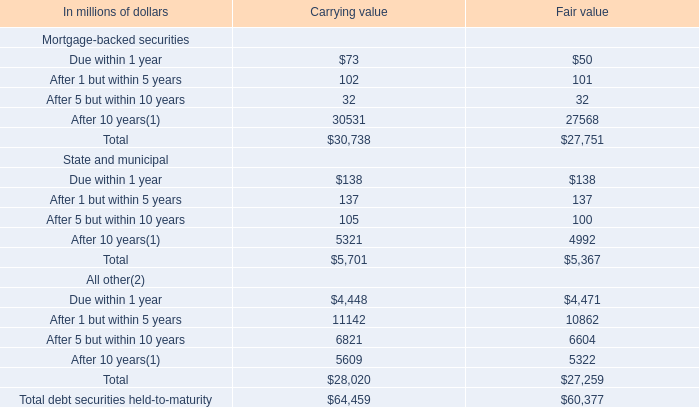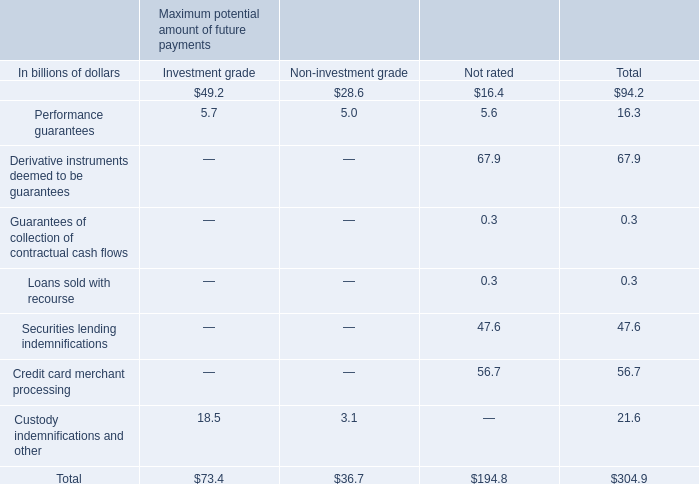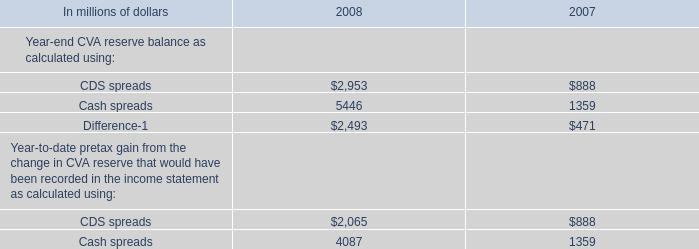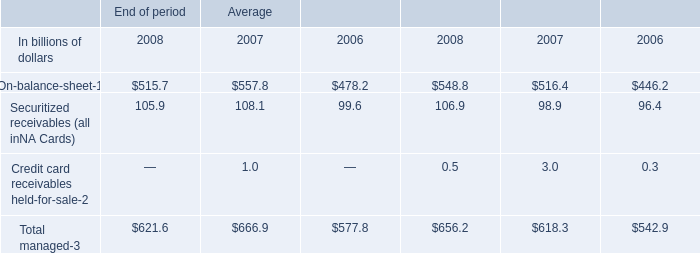What is the sum of Cash spreads of 2008, After 10 years of Carrying value, and Total State and municipal of Carrying value ? 
Computations: ((5446.0 + 30531.0) + 5701.0)
Answer: 41678.0. 